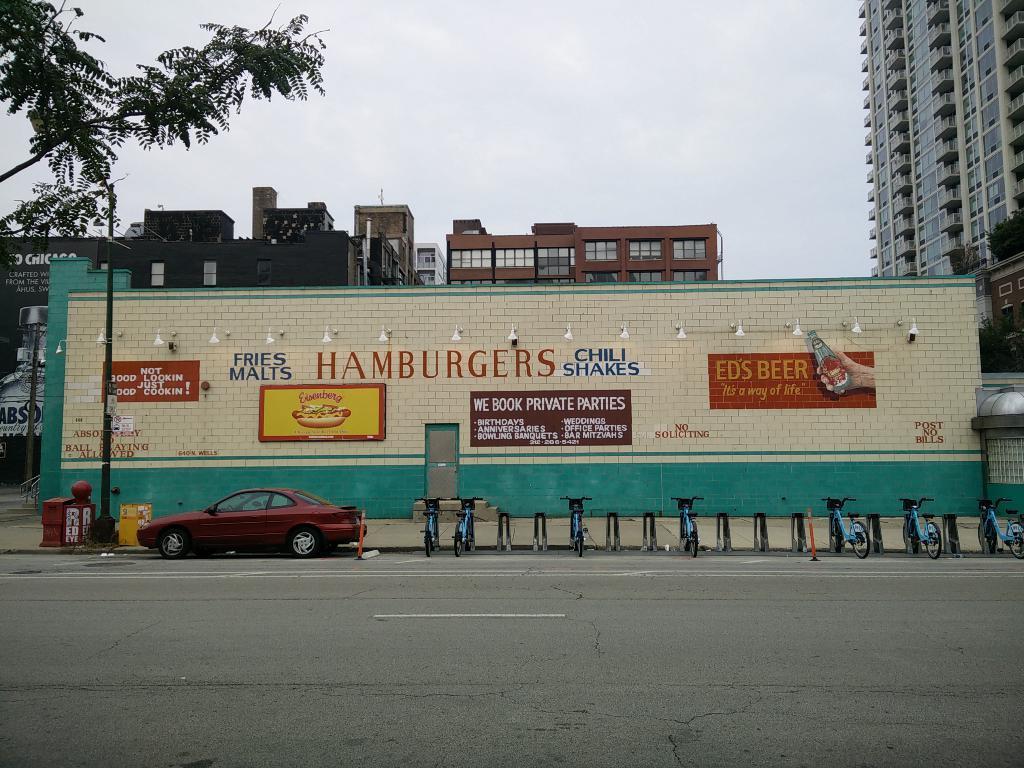Describe this image in one or two sentences. In this image we can see the road, maroon color car and a few bicycles are parked on the side of the road. In the background, we can see the pole, brick wall on which some text is painted and a board is fixed. Here we can see the door. Also, we can see buildings, trees and the cloudy sky. 